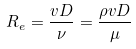Convert formula to latex. <formula><loc_0><loc_0><loc_500><loc_500>R _ { e } = { \frac { v D } { \nu } } = { \frac { \rho v D } { \mu } }</formula> 